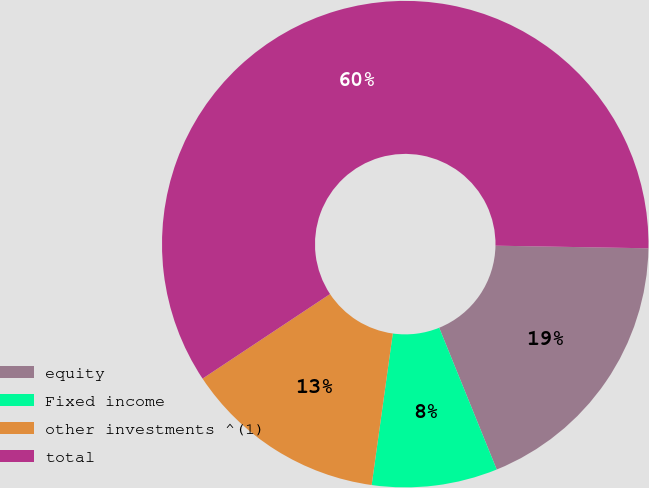<chart> <loc_0><loc_0><loc_500><loc_500><pie_chart><fcel>equity<fcel>Fixed income<fcel>other investments ^(1)<fcel>total<nl><fcel>18.59%<fcel>8.34%<fcel>13.47%<fcel>59.59%<nl></chart> 